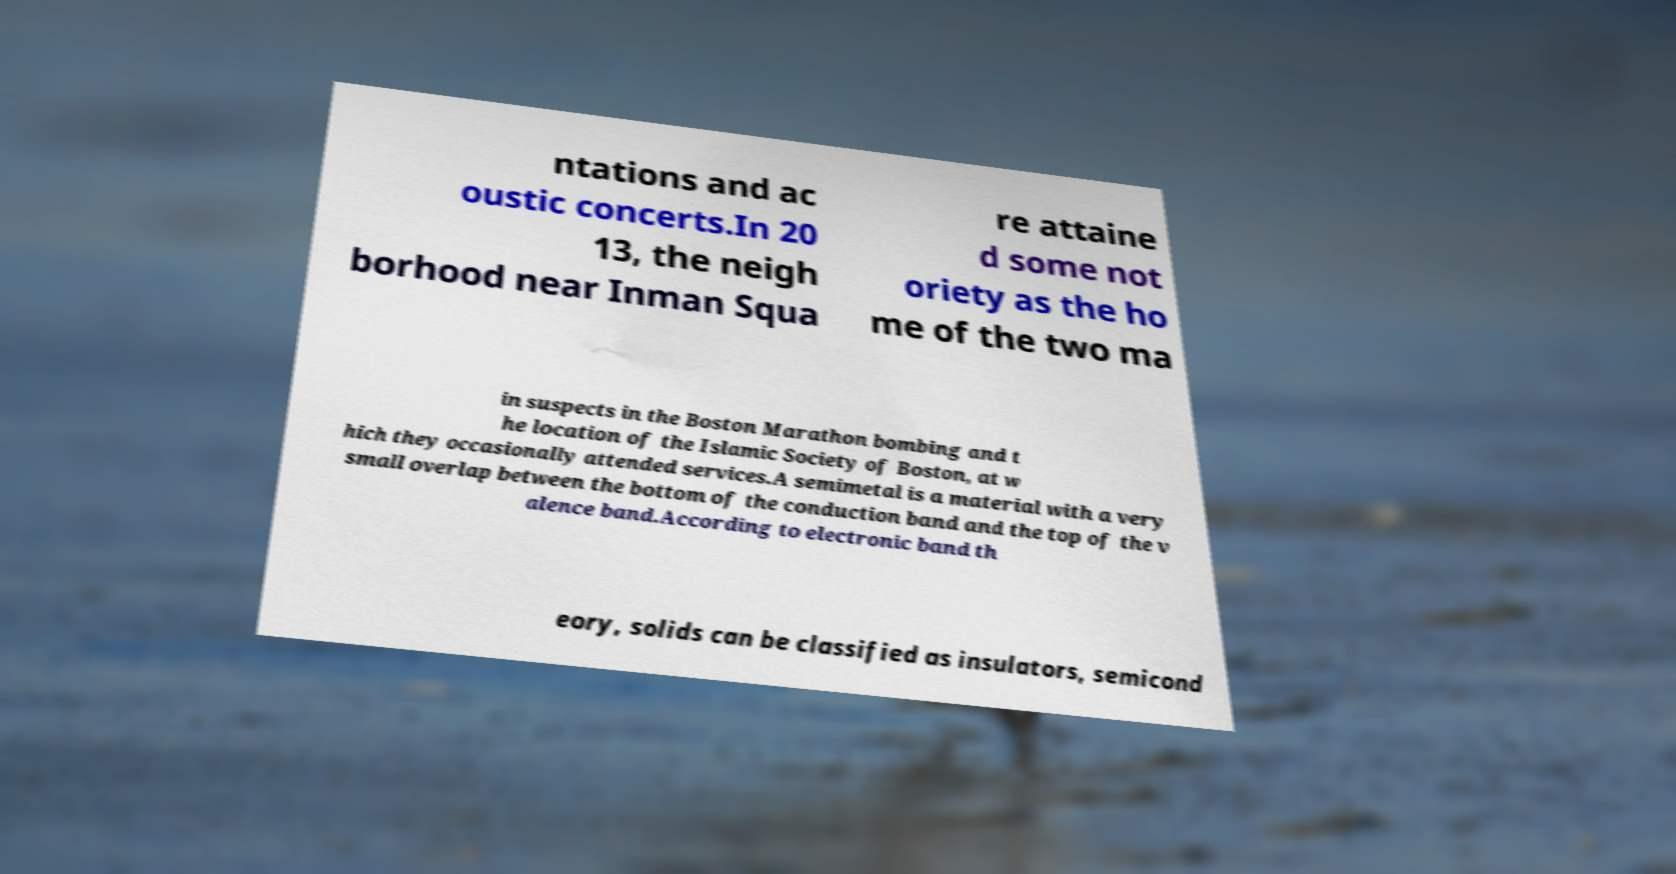There's text embedded in this image that I need extracted. Can you transcribe it verbatim? ntations and ac oustic concerts.In 20 13, the neigh borhood near Inman Squa re attaine d some not oriety as the ho me of the two ma in suspects in the Boston Marathon bombing and t he location of the Islamic Society of Boston, at w hich they occasionally attended services.A semimetal is a material with a very small overlap between the bottom of the conduction band and the top of the v alence band.According to electronic band th eory, solids can be classified as insulators, semicond 